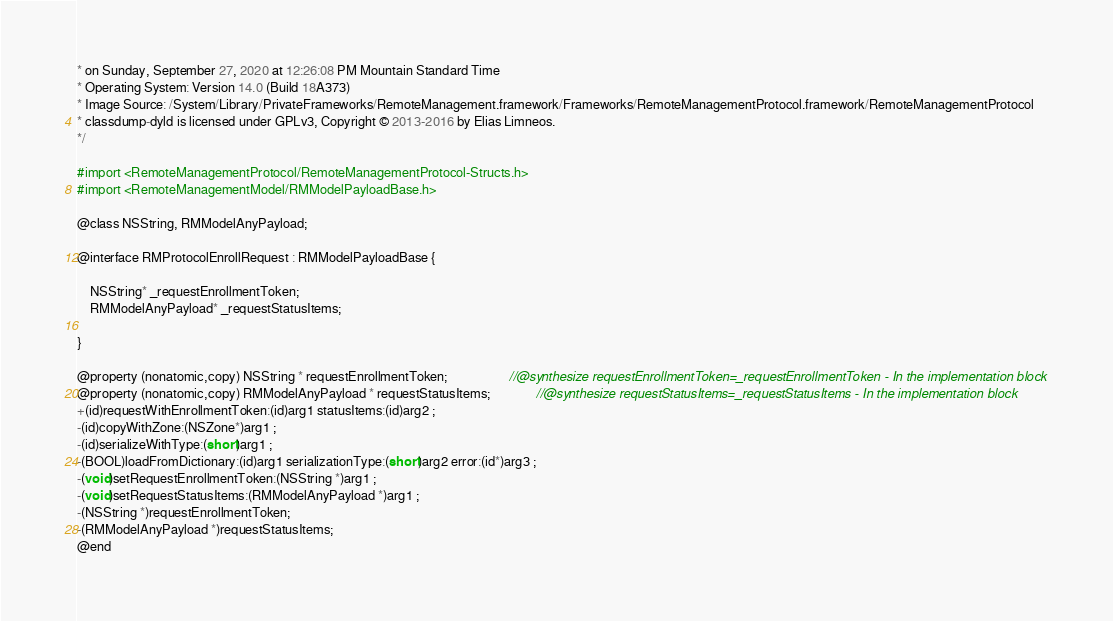<code> <loc_0><loc_0><loc_500><loc_500><_C_>* on Sunday, September 27, 2020 at 12:26:08 PM Mountain Standard Time
* Operating System: Version 14.0 (Build 18A373)
* Image Source: /System/Library/PrivateFrameworks/RemoteManagement.framework/Frameworks/RemoteManagementProtocol.framework/RemoteManagementProtocol
* classdump-dyld is licensed under GPLv3, Copyright © 2013-2016 by Elias Limneos.
*/

#import <RemoteManagementProtocol/RemoteManagementProtocol-Structs.h>
#import <RemoteManagementModel/RMModelPayloadBase.h>

@class NSString, RMModelAnyPayload;

@interface RMProtocolEnrollRequest : RMModelPayloadBase {

	NSString* _requestEnrollmentToken;
	RMModelAnyPayload* _requestStatusItems;

}

@property (nonatomic,copy) NSString * requestEnrollmentToken;                   //@synthesize requestEnrollmentToken=_requestEnrollmentToken - In the implementation block
@property (nonatomic,copy) RMModelAnyPayload * requestStatusItems;              //@synthesize requestStatusItems=_requestStatusItems - In the implementation block
+(id)requestWithEnrollmentToken:(id)arg1 statusItems:(id)arg2 ;
-(id)copyWithZone:(NSZone*)arg1 ;
-(id)serializeWithType:(short)arg1 ;
-(BOOL)loadFromDictionary:(id)arg1 serializationType:(short)arg2 error:(id*)arg3 ;
-(void)setRequestEnrollmentToken:(NSString *)arg1 ;
-(void)setRequestStatusItems:(RMModelAnyPayload *)arg1 ;
-(NSString *)requestEnrollmentToken;
-(RMModelAnyPayload *)requestStatusItems;
@end

</code> 